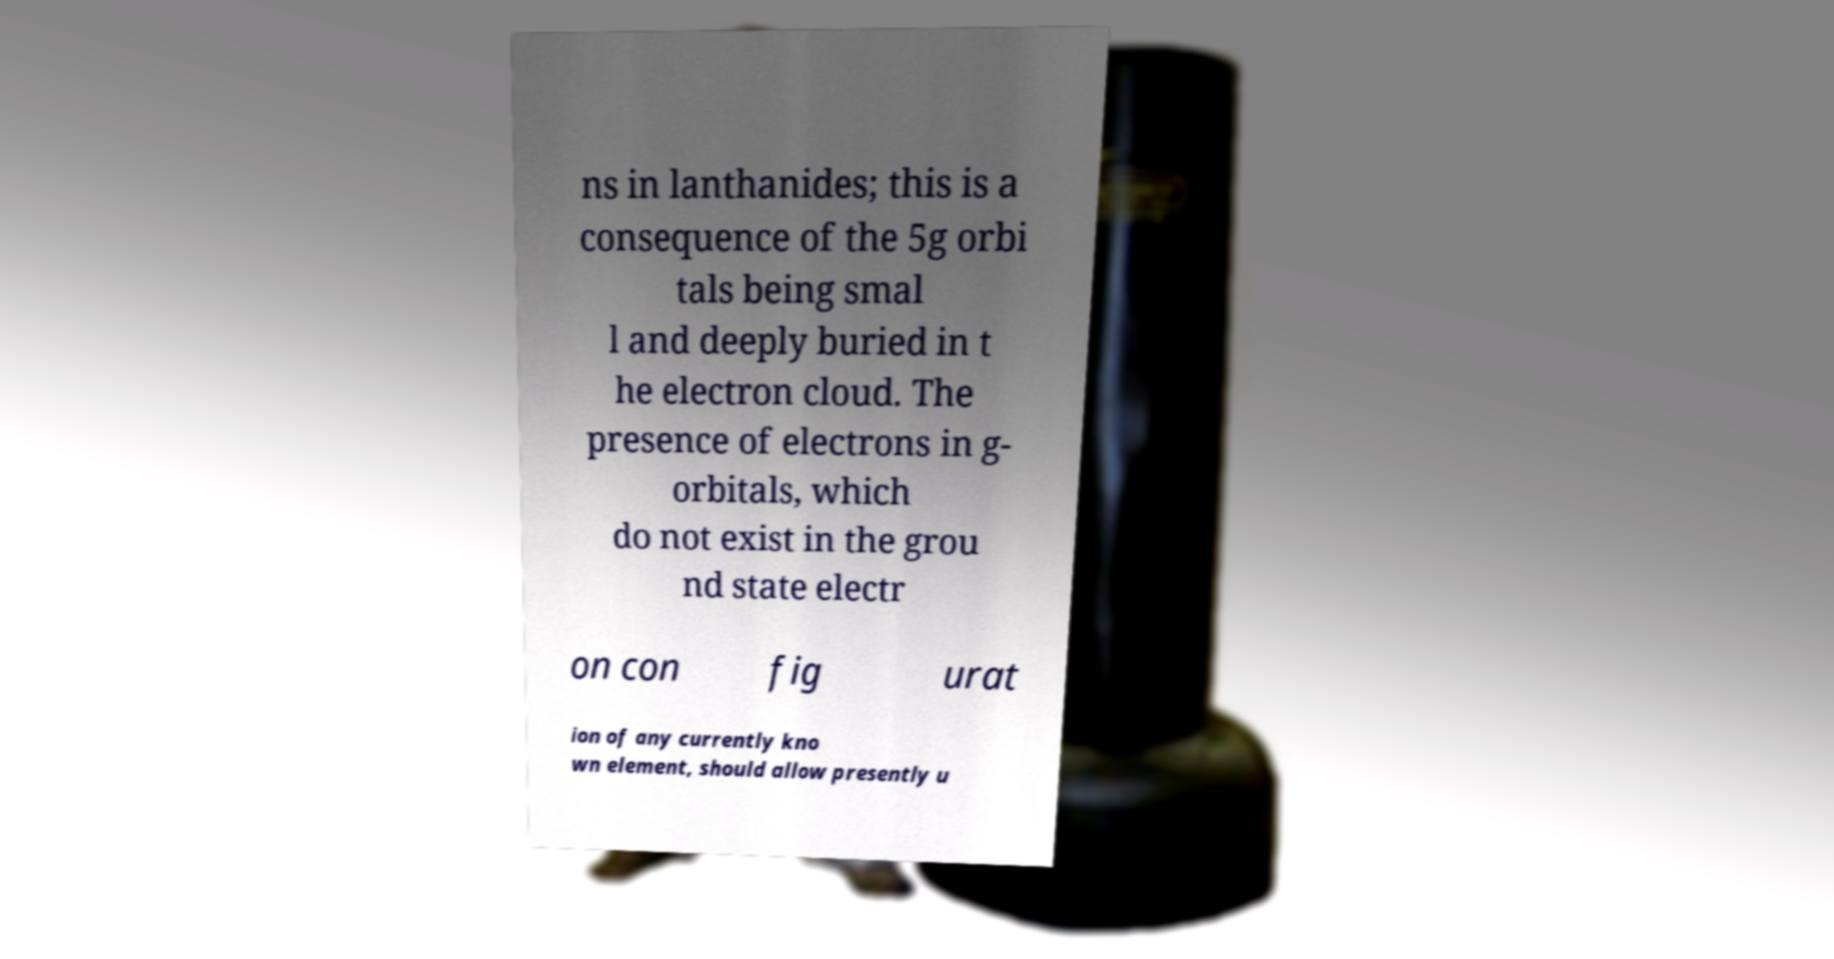Can you read and provide the text displayed in the image?This photo seems to have some interesting text. Can you extract and type it out for me? ns in lanthanides; this is a consequence of the 5g orbi tals being smal l and deeply buried in t he electron cloud. The presence of electrons in g- orbitals, which do not exist in the grou nd state electr on con fig urat ion of any currently kno wn element, should allow presently u 